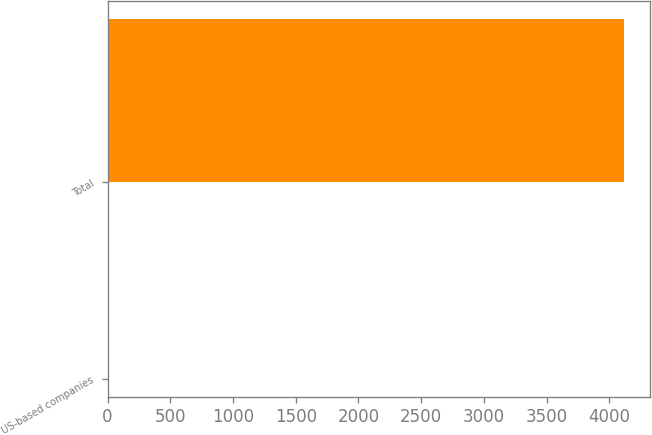Convert chart. <chart><loc_0><loc_0><loc_500><loc_500><bar_chart><fcel>US-based companies<fcel>Total<nl><fcel>7<fcel>4116<nl></chart> 